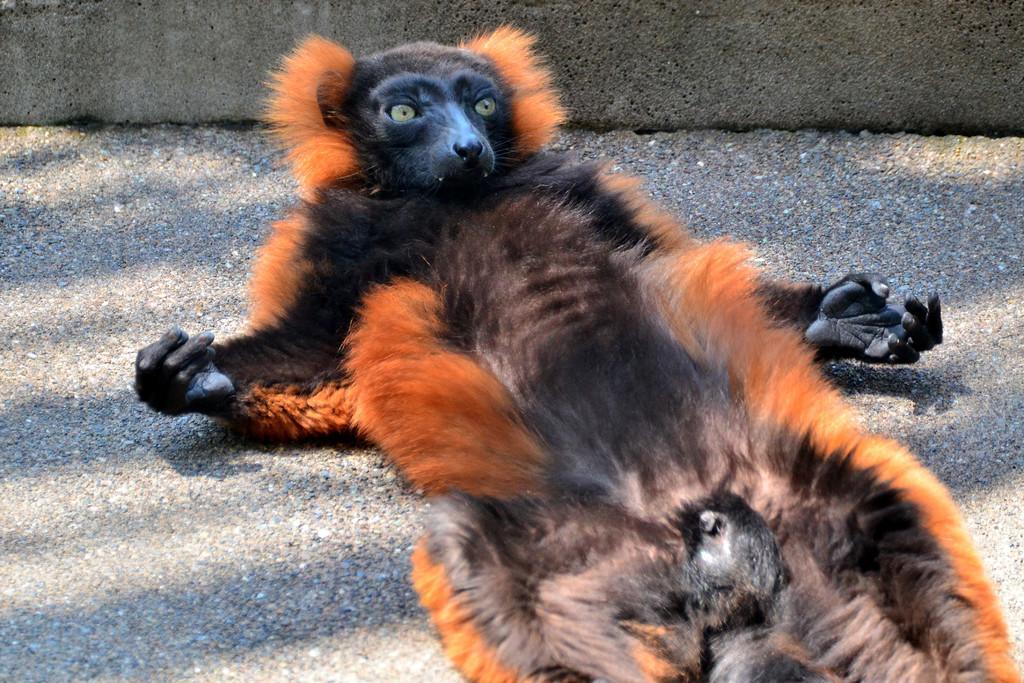Can you describe this image briefly? In this picture there is an animal on the road, which is in orange and black. 